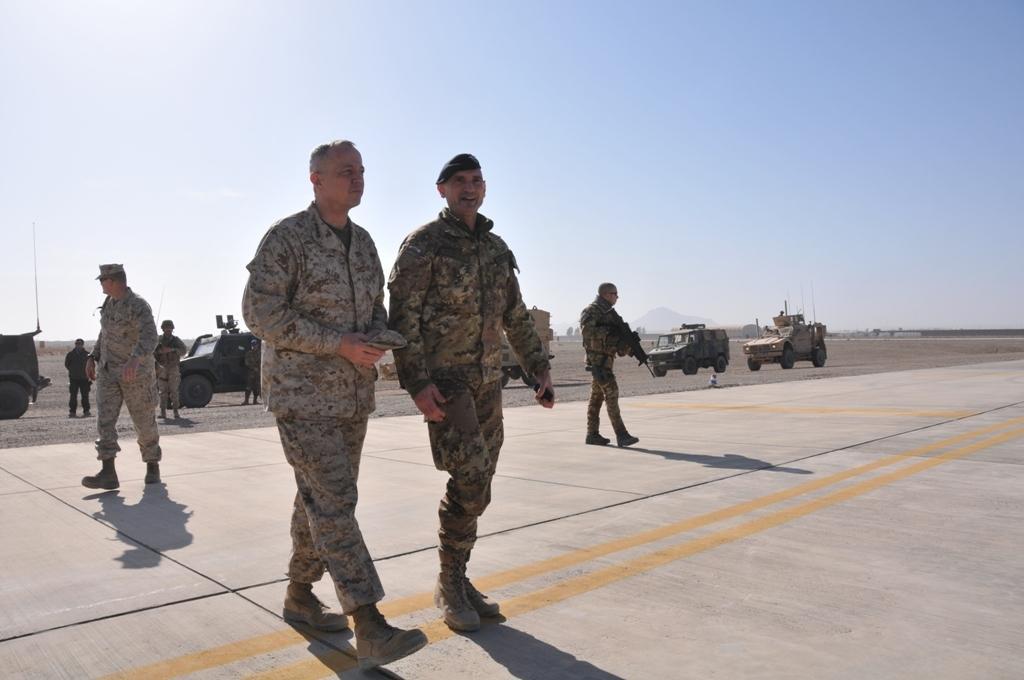In one or two sentences, can you explain what this image depicts? In this picture there is a man who is wearing cap, shirt, trouser and shoe. Beside him there is another man who is wearing shirt, shoes and holding a cap. In the back I can see many soldiers who are holding a gun and standing near to the trucks. In the background I can see the mountains and trees. At the top I can see the sky. 